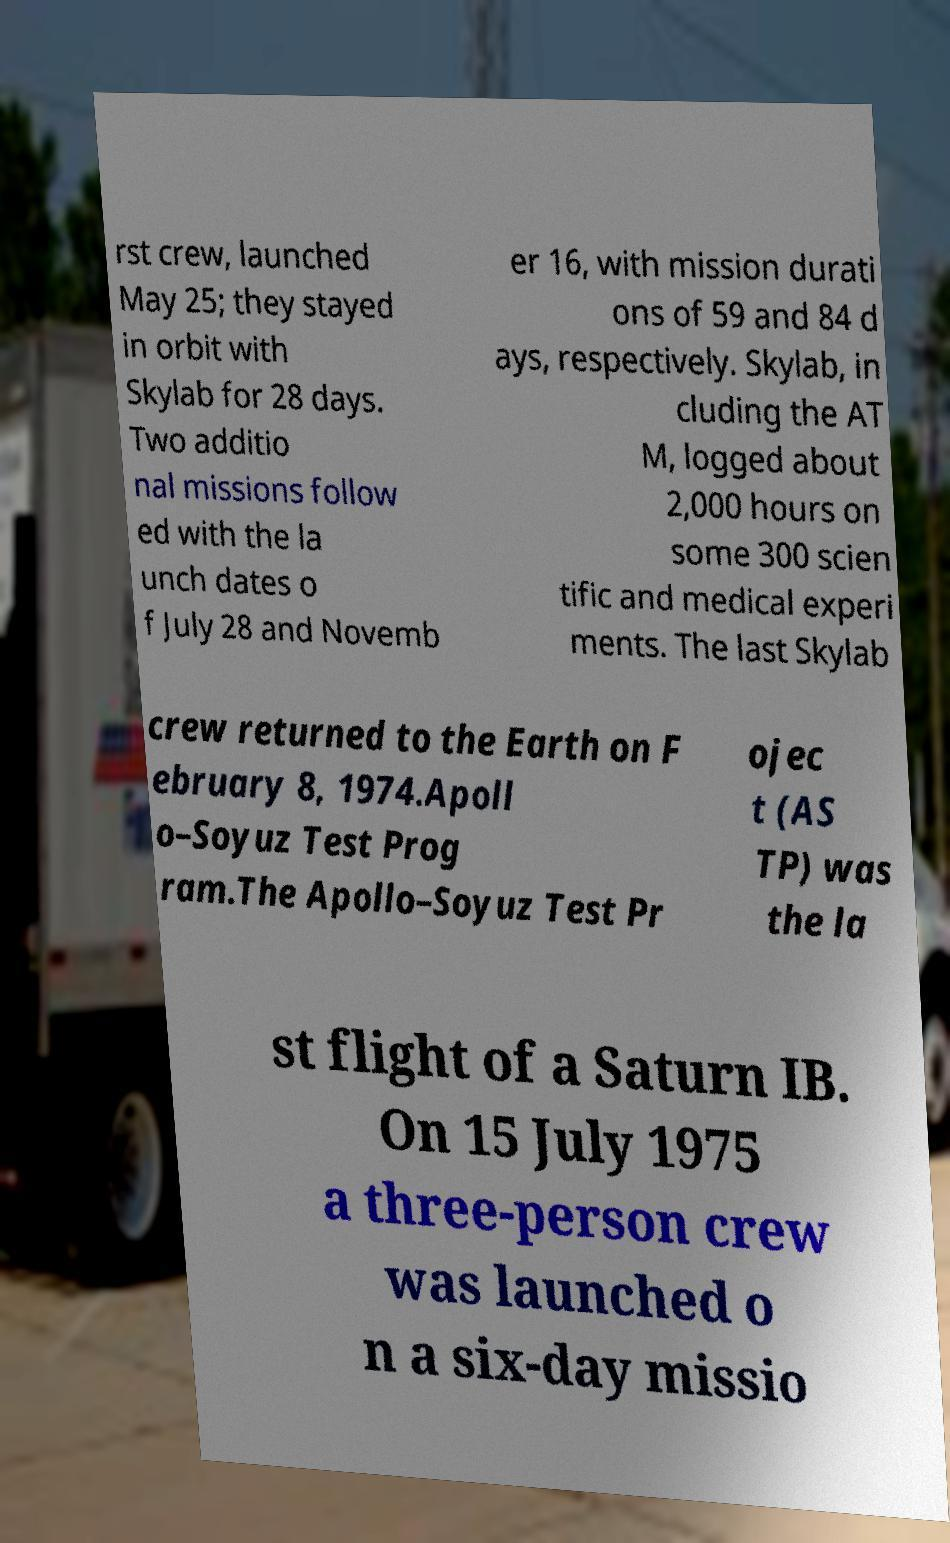Could you extract and type out the text from this image? rst crew, launched May 25; they stayed in orbit with Skylab for 28 days. Two additio nal missions follow ed with the la unch dates o f July 28 and Novemb er 16, with mission durati ons of 59 and 84 d ays, respectively. Skylab, in cluding the AT M, logged about 2,000 hours on some 300 scien tific and medical experi ments. The last Skylab crew returned to the Earth on F ebruary 8, 1974.Apoll o–Soyuz Test Prog ram.The Apollo–Soyuz Test Pr ojec t (AS TP) was the la st flight of a Saturn IB. On 15 July 1975 a three-person crew was launched o n a six-day missio 